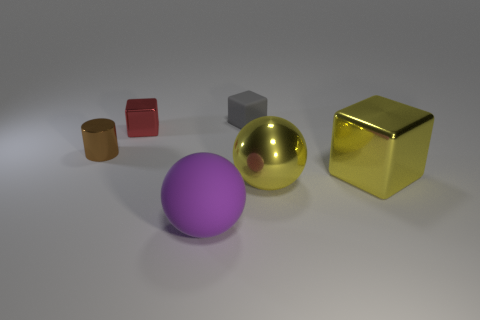What color is the thing on the right side of the large yellow thing left of the yellow cube? The item to the right of the large yellow spherical object, which is located to the left of the yellow cube, appears to be a red cube. 